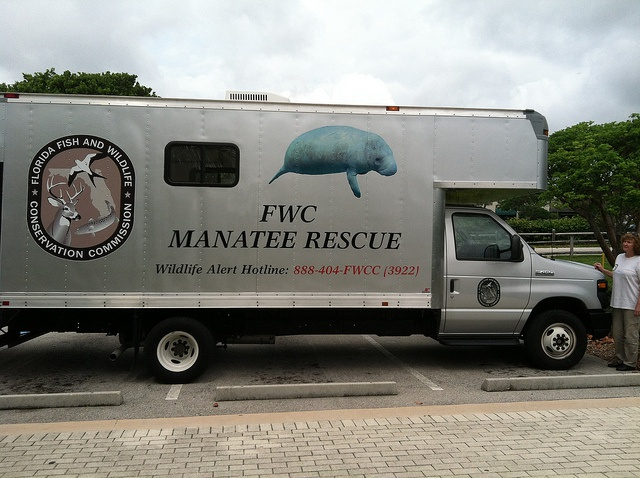Describe the objects in this image and their specific colors. I can see truck in lightgray, gray, darkgray, and black tones, people in lightgray, black, darkgray, and gray tones, and bird in lightgray, black, darkgray, and gray tones in this image. 